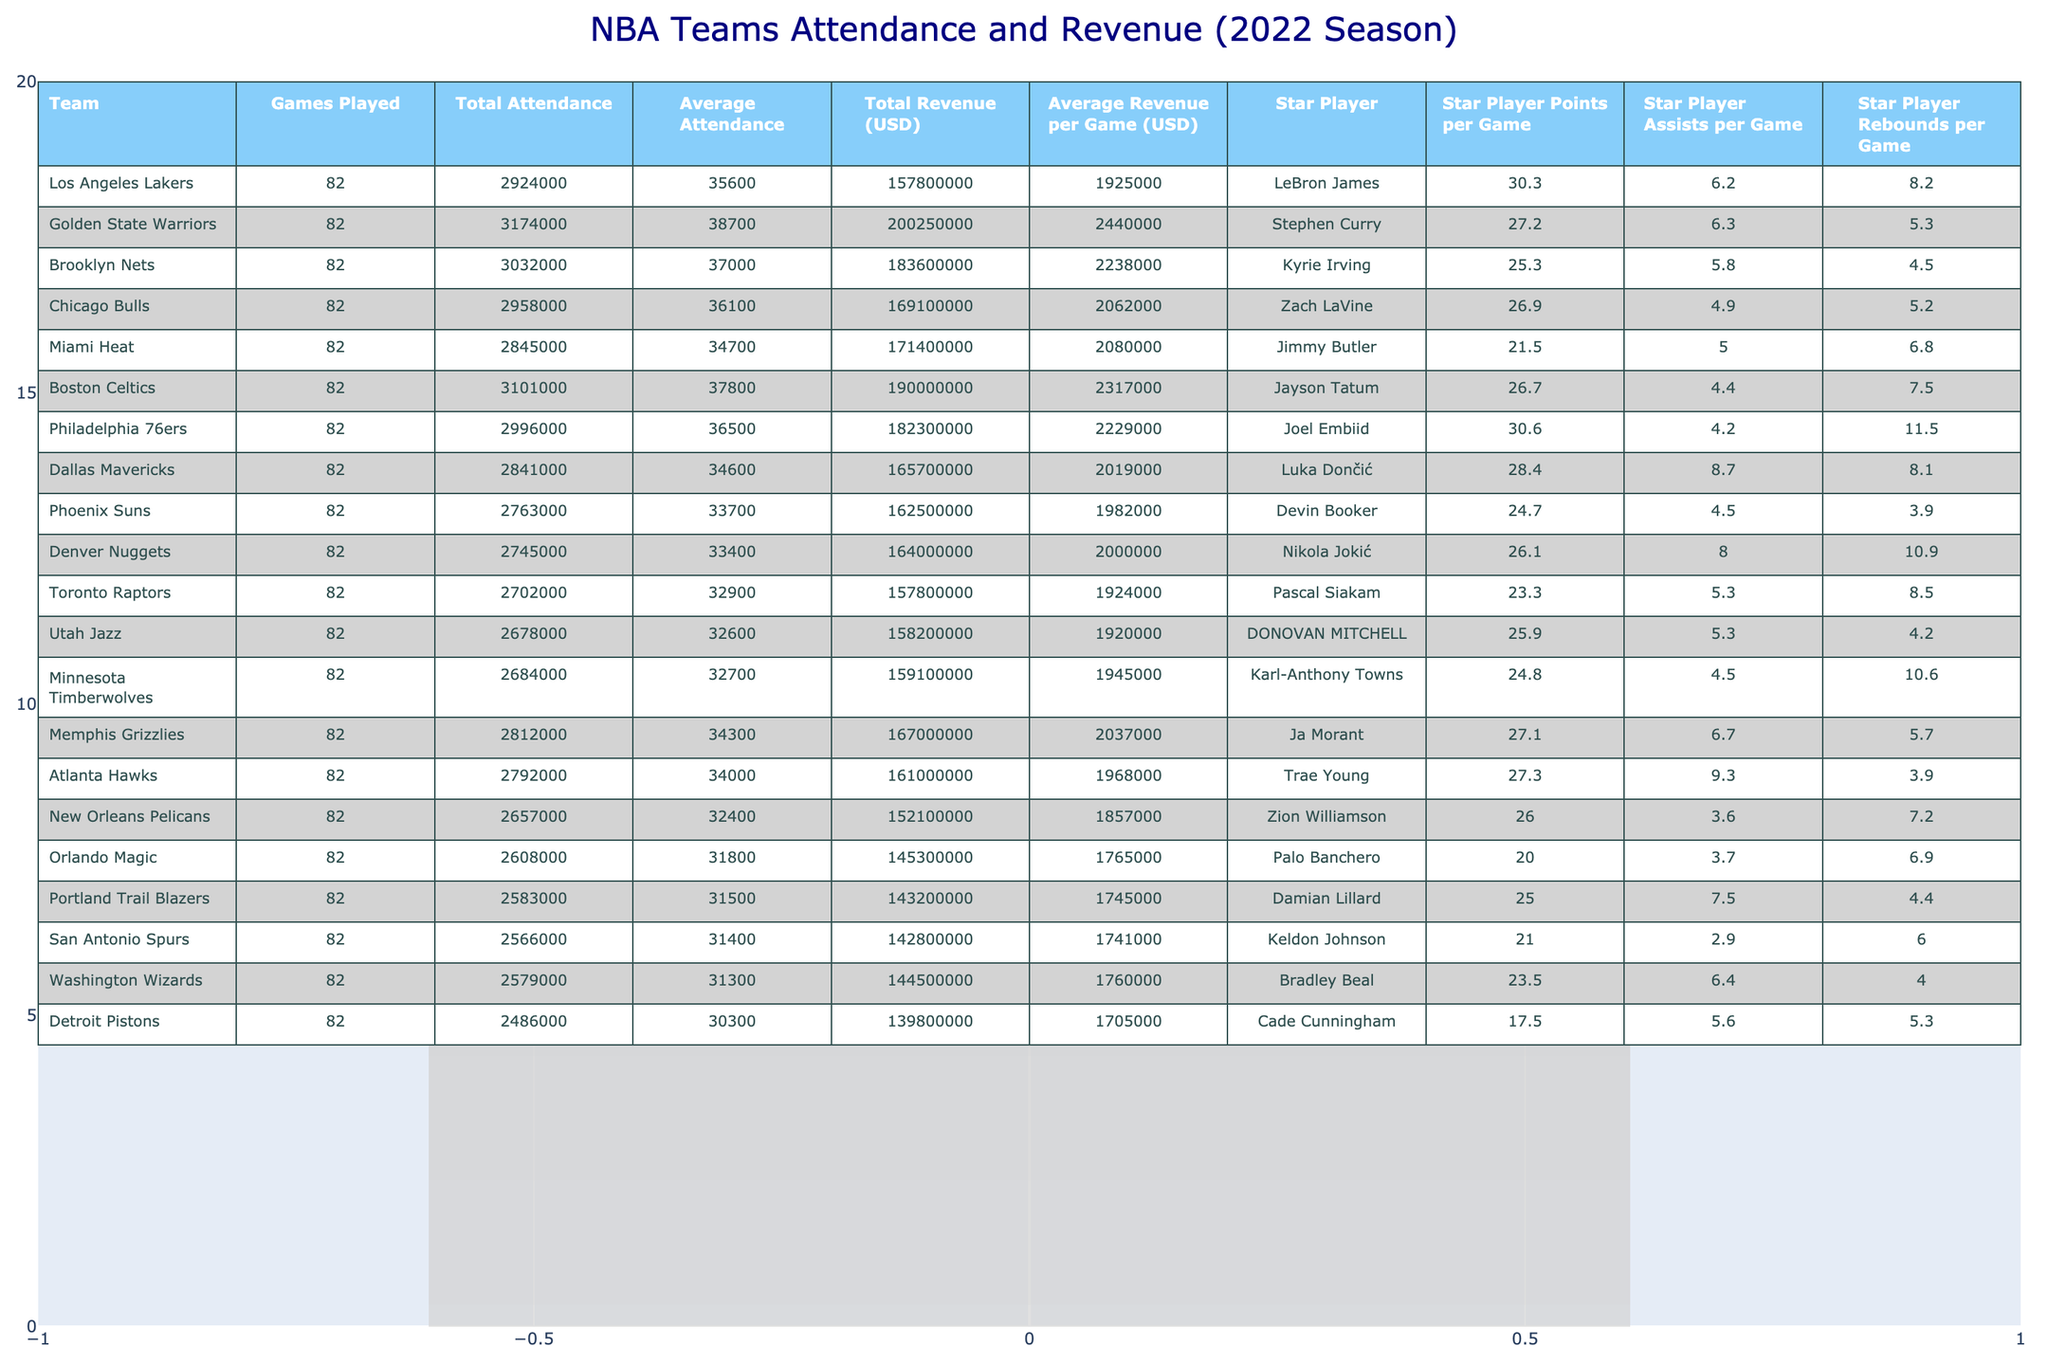What was the total attendance for the Golden State Warriors? The total attendance for the Golden State Warriors is provided directly in the table, listed under "Total Attendance," which is 3,174,000.
Answer: 3,174,000 Which team's star player had the highest points per game? By checking the "Star Player Points per Game" column, LeBron James from the Los Angeles Lakers has the highest points per game at 30.3.
Answer: LeBron James What is the average revenue per game for the Boston Celtics? The average revenue per game for the Boston Celtics can be found in the "Average Revenue per Game (USD)" column, which shows a figure of 2,317,000.
Answer: 2,317,000 Which team had the lowest total revenue? The team with the lowest total revenue can be identified by examining the "Total Revenue (USD)" column, where the Detroit Pistons have a total revenue of 139,800,000.
Answer: Detroit Pistons How many games did the Miami Heat play? The number of games played by the Miami Heat is listed in the "Games Played" column, which states they played 82 games.
Answer: 82 What is the difference in average attendance between the Brooklyn Nets and the Portland Trail Blazers? To find the difference, take the average attendance of the Brooklyn Nets (37,000) and subtract the average attendance of the Portland Trail Blazers (31,500), which results in 37,000 - 31,500 = 5,500.
Answer: 5,500 Did the Philadelphia 76ers have a higher average revenue per game than the Miami Heat? Comparing the "Average Revenue per Game (USD)" for the 76ers (2,229,000) and the Heat (2,080,000), we can see that the 76ers had higher revenue per game.
Answer: Yes What percentage of total attendance did the Los Angeles Lakers achieve compared to the league total? First, we calculate the league's total attendance by summing all teams' total attendances. Then, calculate the Lakers' percentage by dividing their total attendance (2,924,000) by the league's total attendance and multiplying by 100. The total attendance sums to approximately 63,129,000. Thus, (2,924,000 / 63,129,000) * 100 = 4.63%.
Answer: 4.63% Which star player had the lowest rebounds per game and what was that value? Referring to the "Star Player Rebounds per Game" column, Cade Cunningham from the Detroit Pistons has the lowest rebounds per game at 5.3.
Answer: Cade Cunningham, 5.3 What is the average total revenue of the top three teams with the highest average attendance? The top three teams by average attendance are the Golden State Warriors, Brooklyn Nets, and Boston Celtics. Their total revenues are 200,250,000, 183,600,000, and 190,000,000, respectively. Summing those gives 200,250,000 + 183,600,000 + 190,000,000 = 573,850,000. Dividing by 3 gives the average total revenue of 191,283,333.
Answer: 191,283,333 